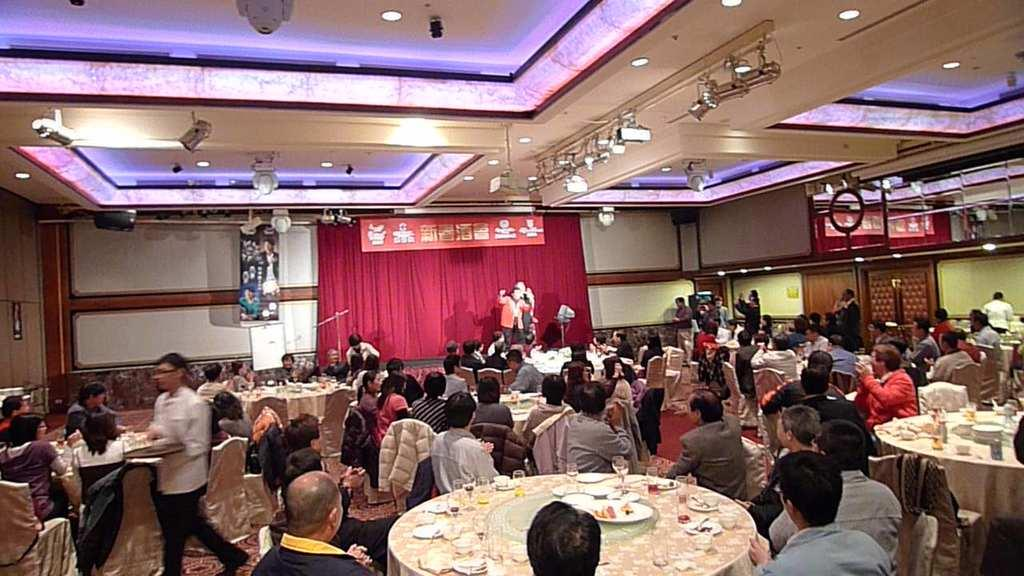What type of space is depicted in the image? The image shows an open room. What are the people in the room doing? People are seated on chairs in the room, and two people are performing on a dais. Who is serving food in the image? A man is serving food in the image. What emotion is the fear depicted in the image? There is no emotion called "fear" depicted in the image. The image shows people seated in a room and others performing on a dais, with a man serving food. 